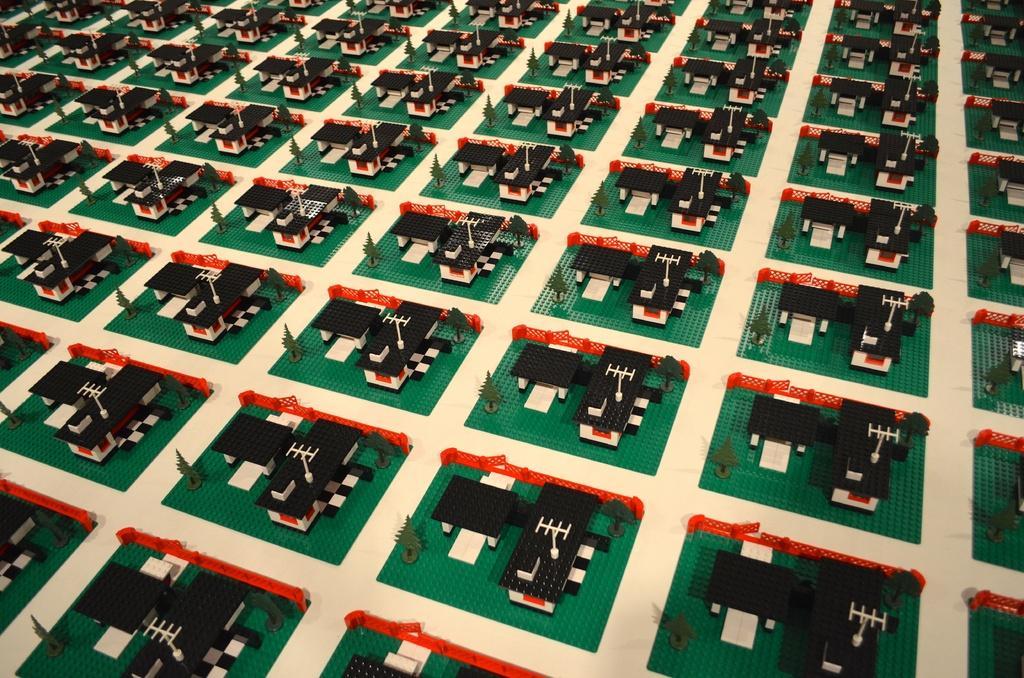Could you give a brief overview of what you see in this image? This picture is consists of carpet design in the image. 